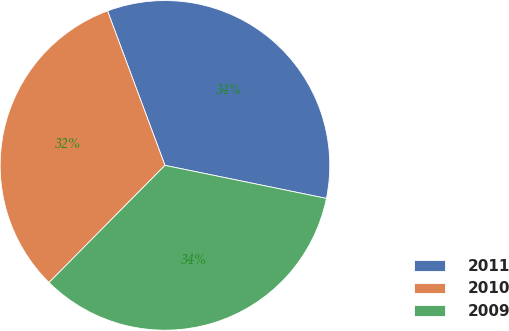Convert chart to OTSL. <chart><loc_0><loc_0><loc_500><loc_500><pie_chart><fcel>2011<fcel>2010<fcel>2009<nl><fcel>33.88%<fcel>31.92%<fcel>34.21%<nl></chart> 